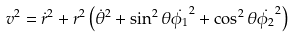<formula> <loc_0><loc_0><loc_500><loc_500>v ^ { 2 } = \dot { r } ^ { 2 } + r ^ { 2 } \left ( \dot { \theta } ^ { 2 } + \sin ^ { 2 } \theta \dot { \phi _ { 1 } } ^ { 2 } + \cos ^ { 2 } \theta \dot { \phi _ { 2 } } ^ { 2 } \right ) \label l { v e e }</formula> 